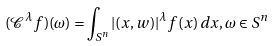Convert formula to latex. <formula><loc_0><loc_0><loc_500><loc_500>( \mathcal { C } ^ { \lambda } f ) ( \omega ) = \int _ { S ^ { n } } | ( x , w ) | ^ { \lambda } f ( x ) \, d x , \omega \in S ^ { n }</formula> 